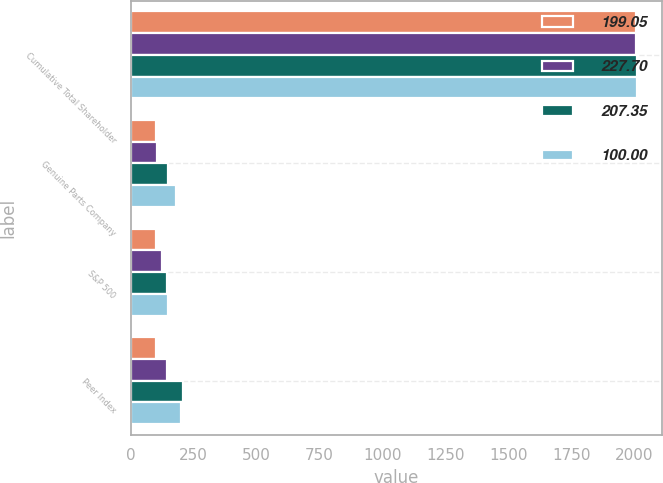Convert chart to OTSL. <chart><loc_0><loc_0><loc_500><loc_500><stacked_bar_chart><ecel><fcel>Cumulative Total Shareholder<fcel>Genuine Parts Company<fcel>S&P 500<fcel>Peer Index<nl><fcel>199.05<fcel>2008<fcel>100<fcel>100<fcel>100<nl><fcel>227.7<fcel>2009<fcel>105.22<fcel>126.46<fcel>142.97<nl><fcel>207.35<fcel>2010<fcel>147.87<fcel>145.5<fcel>207.35<nl><fcel>100<fcel>2011<fcel>182.23<fcel>148.58<fcel>199.05<nl></chart> 